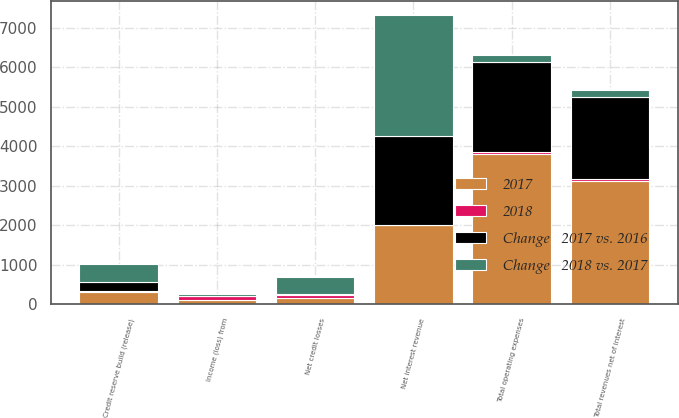<chart> <loc_0><loc_0><loc_500><loc_500><stacked_bar_chart><ecel><fcel>Net interest revenue<fcel>Total revenues net of interest<fcel>Total operating expenses<fcel>Net credit losses<fcel>Credit reserve build (release)<fcel>Income (loss) from<nl><fcel>Change   2017 vs. 2016<fcel>2254<fcel>2083<fcel>2272<fcel>21<fcel>218<fcel>8<nl><fcel>2017<fcel>2000<fcel>3132<fcel>3814<fcel>149<fcel>317<fcel>111<nl><fcel>Change   2018 vs. 2017<fcel>3045<fcel>183.5<fcel>183.5<fcel>435<fcel>456<fcel>58<nl><fcel>2018<fcel>13<fcel>33<fcel>40<fcel>86<fcel>31<fcel>93<nl></chart> 